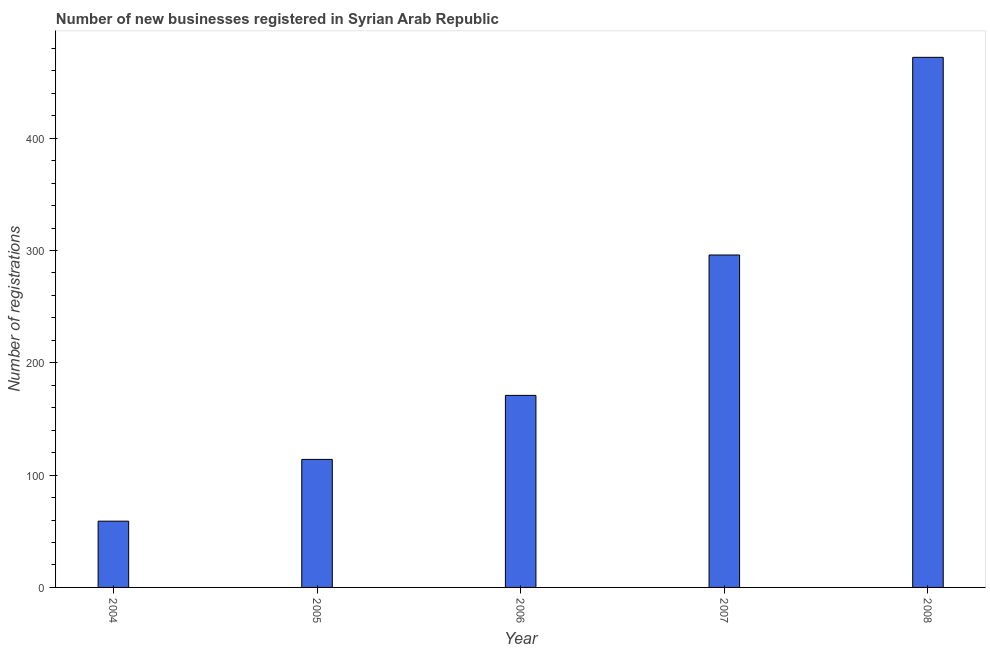Does the graph contain any zero values?
Your answer should be compact. No. What is the title of the graph?
Make the answer very short. Number of new businesses registered in Syrian Arab Republic. What is the label or title of the X-axis?
Offer a very short reply. Year. What is the label or title of the Y-axis?
Keep it short and to the point. Number of registrations. Across all years, what is the maximum number of new business registrations?
Your response must be concise. 472. Across all years, what is the minimum number of new business registrations?
Your response must be concise. 59. In which year was the number of new business registrations minimum?
Offer a terse response. 2004. What is the sum of the number of new business registrations?
Offer a very short reply. 1112. What is the difference between the number of new business registrations in 2006 and 2008?
Your response must be concise. -301. What is the average number of new business registrations per year?
Your response must be concise. 222. What is the median number of new business registrations?
Your answer should be compact. 171. Do a majority of the years between 2006 and 2004 (inclusive) have number of new business registrations greater than 120 ?
Give a very brief answer. Yes. What is the ratio of the number of new business registrations in 2004 to that in 2006?
Provide a short and direct response. 0.34. What is the difference between the highest and the second highest number of new business registrations?
Ensure brevity in your answer.  176. What is the difference between the highest and the lowest number of new business registrations?
Your answer should be compact. 413. How many bars are there?
Keep it short and to the point. 5. How many years are there in the graph?
Make the answer very short. 5. Are the values on the major ticks of Y-axis written in scientific E-notation?
Provide a short and direct response. No. What is the Number of registrations in 2005?
Give a very brief answer. 114. What is the Number of registrations in 2006?
Offer a terse response. 171. What is the Number of registrations of 2007?
Provide a short and direct response. 296. What is the Number of registrations in 2008?
Keep it short and to the point. 472. What is the difference between the Number of registrations in 2004 and 2005?
Keep it short and to the point. -55. What is the difference between the Number of registrations in 2004 and 2006?
Your answer should be compact. -112. What is the difference between the Number of registrations in 2004 and 2007?
Your response must be concise. -237. What is the difference between the Number of registrations in 2004 and 2008?
Ensure brevity in your answer.  -413. What is the difference between the Number of registrations in 2005 and 2006?
Your response must be concise. -57. What is the difference between the Number of registrations in 2005 and 2007?
Your answer should be very brief. -182. What is the difference between the Number of registrations in 2005 and 2008?
Offer a very short reply. -358. What is the difference between the Number of registrations in 2006 and 2007?
Provide a short and direct response. -125. What is the difference between the Number of registrations in 2006 and 2008?
Provide a succinct answer. -301. What is the difference between the Number of registrations in 2007 and 2008?
Provide a short and direct response. -176. What is the ratio of the Number of registrations in 2004 to that in 2005?
Keep it short and to the point. 0.52. What is the ratio of the Number of registrations in 2004 to that in 2006?
Provide a succinct answer. 0.34. What is the ratio of the Number of registrations in 2004 to that in 2007?
Offer a terse response. 0.2. What is the ratio of the Number of registrations in 2005 to that in 2006?
Keep it short and to the point. 0.67. What is the ratio of the Number of registrations in 2005 to that in 2007?
Keep it short and to the point. 0.39. What is the ratio of the Number of registrations in 2005 to that in 2008?
Keep it short and to the point. 0.24. What is the ratio of the Number of registrations in 2006 to that in 2007?
Keep it short and to the point. 0.58. What is the ratio of the Number of registrations in 2006 to that in 2008?
Give a very brief answer. 0.36. What is the ratio of the Number of registrations in 2007 to that in 2008?
Your answer should be compact. 0.63. 